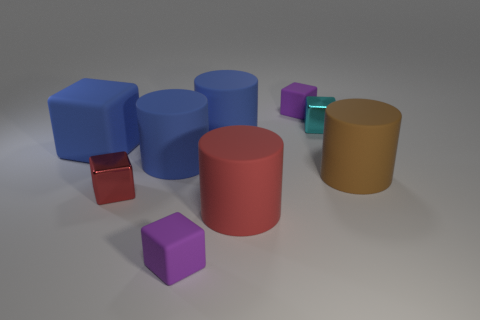Are the big red cylinder and the large brown object made of the same material?
Your response must be concise. Yes. What size is the thing that is right of the shiny cube that is behind the big brown cylinder?
Provide a succinct answer. Large. What is the color of the shiny thing left of the purple block right of the small purple block in front of the big red matte cylinder?
Provide a succinct answer. Red. What is the size of the thing that is both behind the brown matte cylinder and in front of the large blue matte cube?
Your answer should be very brief. Large. Is there a large red object on the left side of the tiny purple matte thing that is in front of the small rubber thing that is behind the tiny red metallic thing?
Keep it short and to the point. No. There is another metallic object that is the same shape as the cyan shiny thing; what is its color?
Keep it short and to the point. Red. What material is the red object that is on the right side of the blue matte object in front of the big matte block?
Your answer should be compact. Rubber. Is the small red object the same shape as the small cyan metal object?
Give a very brief answer. Yes. What is the color of the other shiny thing that is the same size as the red shiny thing?
Provide a succinct answer. Cyan. Is the small cube in front of the small red metallic object made of the same material as the small cyan thing?
Ensure brevity in your answer.  No. 